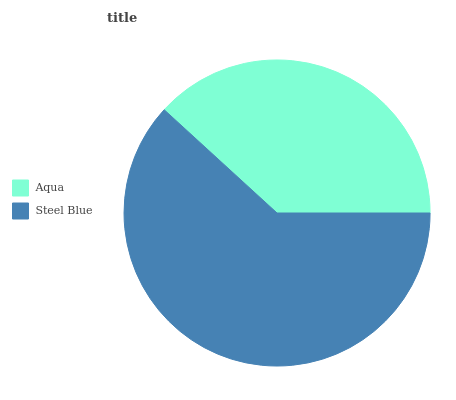Is Aqua the minimum?
Answer yes or no. Yes. Is Steel Blue the maximum?
Answer yes or no. Yes. Is Steel Blue the minimum?
Answer yes or no. No. Is Steel Blue greater than Aqua?
Answer yes or no. Yes. Is Aqua less than Steel Blue?
Answer yes or no. Yes. Is Aqua greater than Steel Blue?
Answer yes or no. No. Is Steel Blue less than Aqua?
Answer yes or no. No. Is Steel Blue the high median?
Answer yes or no. Yes. Is Aqua the low median?
Answer yes or no. Yes. Is Aqua the high median?
Answer yes or no. No. Is Steel Blue the low median?
Answer yes or no. No. 